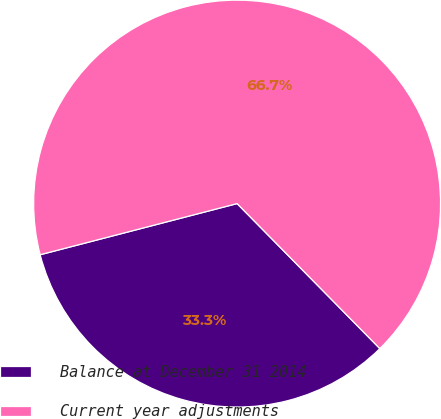<chart> <loc_0><loc_0><loc_500><loc_500><pie_chart><fcel>Balance at December 31 2014<fcel>Current year adjustments<nl><fcel>33.33%<fcel>66.67%<nl></chart> 